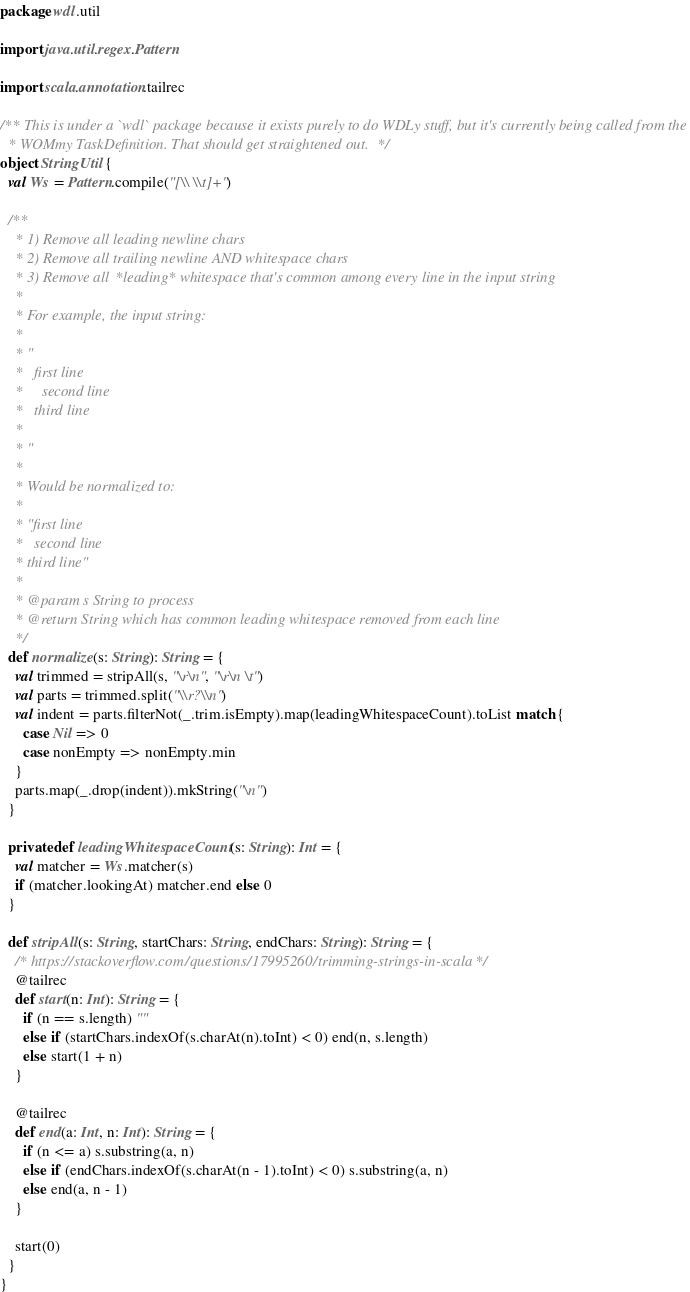<code> <loc_0><loc_0><loc_500><loc_500><_Scala_>package wdl.util

import java.util.regex.Pattern

import scala.annotation.tailrec

/** This is under a `wdl` package because it exists purely to do WDLy stuff, but it's currently being called from the
  * WOMmy TaskDefinition. That should get straightened out. */
object StringUtil {
  val Ws = Pattern.compile("[\\ \\t]+")

  /**
    * 1) Remove all leading newline chars
    * 2) Remove all trailing newline AND whitespace chars
    * 3) Remove all *leading* whitespace that's common among every line in the input string
    *
    * For example, the input string:
    *
    * "
    *   first line
    *     second line
    *   third line
    *
    * "
    *
    * Would be normalized to:
    *
    * "first line
    *   second line
    * third line"
    *
    * @param s String to process
    * @return String which has common leading whitespace removed from each line
    */
  def normalize(s: String): String = {
    val trimmed = stripAll(s, "\r\n", "\r\n \t")
    val parts = trimmed.split("\\r?\\n")
    val indent = parts.filterNot(_.trim.isEmpty).map(leadingWhitespaceCount).toList match {
      case Nil => 0
      case nonEmpty => nonEmpty.min
    }
    parts.map(_.drop(indent)).mkString("\n")
  }

  private def leadingWhitespaceCount(s: String): Int = {
    val matcher = Ws.matcher(s)
    if (matcher.lookingAt) matcher.end else 0
  }

  def stripAll(s: String, startChars: String, endChars: String): String = {
    /* https://stackoverflow.com/questions/17995260/trimming-strings-in-scala */
    @tailrec
    def start(n: Int): String = {
      if (n == s.length) ""
      else if (startChars.indexOf(s.charAt(n).toInt) < 0) end(n, s.length)
      else start(1 + n)
    }

    @tailrec
    def end(a: Int, n: Int): String = {
      if (n <= a) s.substring(a, n)
      else if (endChars.indexOf(s.charAt(n - 1).toInt) < 0) s.substring(a, n)
      else end(a, n - 1)
    }

    start(0)
  }
}
</code> 